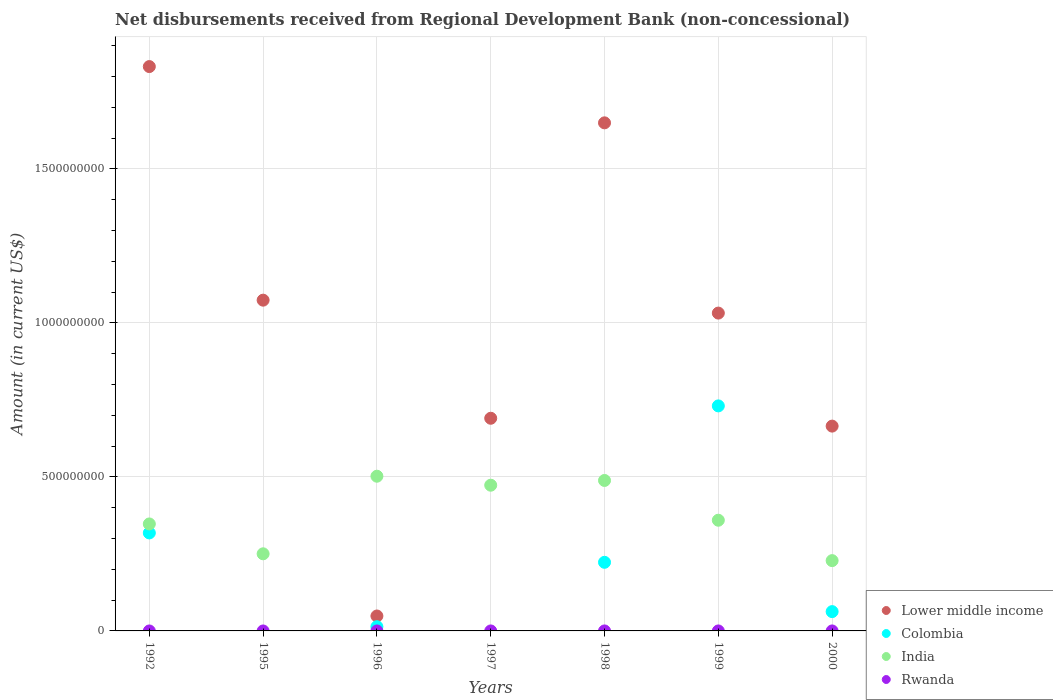How many different coloured dotlines are there?
Offer a very short reply. 3. What is the amount of disbursements received from Regional Development Bank in India in 1992?
Give a very brief answer. 3.47e+08. Across all years, what is the maximum amount of disbursements received from Regional Development Bank in Colombia?
Give a very brief answer. 7.31e+08. What is the total amount of disbursements received from Regional Development Bank in Lower middle income in the graph?
Offer a terse response. 6.99e+09. What is the difference between the amount of disbursements received from Regional Development Bank in Colombia in 1992 and that in 2000?
Your response must be concise. 2.55e+08. What is the difference between the amount of disbursements received from Regional Development Bank in Rwanda in 1992 and the amount of disbursements received from Regional Development Bank in India in 1995?
Your response must be concise. -2.50e+08. What is the average amount of disbursements received from Regional Development Bank in Colombia per year?
Your answer should be very brief. 1.93e+08. In the year 2000, what is the difference between the amount of disbursements received from Regional Development Bank in Colombia and amount of disbursements received from Regional Development Bank in Lower middle income?
Ensure brevity in your answer.  -6.02e+08. In how many years, is the amount of disbursements received from Regional Development Bank in Colombia greater than 100000000 US$?
Give a very brief answer. 3. What is the ratio of the amount of disbursements received from Regional Development Bank in Lower middle income in 1992 to that in 1999?
Provide a succinct answer. 1.78. Is the amount of disbursements received from Regional Development Bank in Colombia in 1996 less than that in 2000?
Offer a terse response. Yes. What is the difference between the highest and the second highest amount of disbursements received from Regional Development Bank in India?
Provide a succinct answer. 1.38e+07. What is the difference between the highest and the lowest amount of disbursements received from Regional Development Bank in India?
Keep it short and to the point. 2.74e+08. In how many years, is the amount of disbursements received from Regional Development Bank in India greater than the average amount of disbursements received from Regional Development Bank in India taken over all years?
Give a very brief answer. 3. Is it the case that in every year, the sum of the amount of disbursements received from Regional Development Bank in Lower middle income and amount of disbursements received from Regional Development Bank in Colombia  is greater than the amount of disbursements received from Regional Development Bank in Rwanda?
Your answer should be compact. Yes. Does the amount of disbursements received from Regional Development Bank in India monotonically increase over the years?
Provide a succinct answer. No. Is the amount of disbursements received from Regional Development Bank in Lower middle income strictly greater than the amount of disbursements received from Regional Development Bank in Rwanda over the years?
Keep it short and to the point. Yes. How many dotlines are there?
Your response must be concise. 3. How many years are there in the graph?
Ensure brevity in your answer.  7. Does the graph contain any zero values?
Provide a short and direct response. Yes. Does the graph contain grids?
Make the answer very short. Yes. Where does the legend appear in the graph?
Provide a short and direct response. Bottom right. How are the legend labels stacked?
Provide a succinct answer. Vertical. What is the title of the graph?
Your answer should be compact. Net disbursements received from Regional Development Bank (non-concessional). What is the label or title of the X-axis?
Provide a short and direct response. Years. What is the Amount (in current US$) in Lower middle income in 1992?
Your response must be concise. 1.83e+09. What is the Amount (in current US$) of Colombia in 1992?
Offer a very short reply. 3.18e+08. What is the Amount (in current US$) in India in 1992?
Make the answer very short. 3.47e+08. What is the Amount (in current US$) in Rwanda in 1992?
Make the answer very short. 0. What is the Amount (in current US$) of Lower middle income in 1995?
Your answer should be very brief. 1.07e+09. What is the Amount (in current US$) in Colombia in 1995?
Make the answer very short. 0. What is the Amount (in current US$) of India in 1995?
Make the answer very short. 2.50e+08. What is the Amount (in current US$) in Lower middle income in 1996?
Give a very brief answer. 4.85e+07. What is the Amount (in current US$) in Colombia in 1996?
Make the answer very short. 1.37e+07. What is the Amount (in current US$) in India in 1996?
Provide a succinct answer. 5.02e+08. What is the Amount (in current US$) in Rwanda in 1996?
Make the answer very short. 0. What is the Amount (in current US$) in Lower middle income in 1997?
Offer a very short reply. 6.91e+08. What is the Amount (in current US$) of India in 1997?
Offer a very short reply. 4.73e+08. What is the Amount (in current US$) of Rwanda in 1997?
Give a very brief answer. 0. What is the Amount (in current US$) of Lower middle income in 1998?
Provide a short and direct response. 1.65e+09. What is the Amount (in current US$) of Colombia in 1998?
Keep it short and to the point. 2.23e+08. What is the Amount (in current US$) in India in 1998?
Your response must be concise. 4.89e+08. What is the Amount (in current US$) in Rwanda in 1998?
Provide a succinct answer. 0. What is the Amount (in current US$) of Lower middle income in 1999?
Your response must be concise. 1.03e+09. What is the Amount (in current US$) in Colombia in 1999?
Offer a very short reply. 7.31e+08. What is the Amount (in current US$) in India in 1999?
Offer a very short reply. 3.59e+08. What is the Amount (in current US$) of Lower middle income in 2000?
Offer a very short reply. 6.65e+08. What is the Amount (in current US$) of Colombia in 2000?
Make the answer very short. 6.27e+07. What is the Amount (in current US$) of India in 2000?
Provide a short and direct response. 2.28e+08. Across all years, what is the maximum Amount (in current US$) of Lower middle income?
Provide a short and direct response. 1.83e+09. Across all years, what is the maximum Amount (in current US$) of Colombia?
Your response must be concise. 7.31e+08. Across all years, what is the maximum Amount (in current US$) of India?
Your answer should be very brief. 5.02e+08. Across all years, what is the minimum Amount (in current US$) in Lower middle income?
Keep it short and to the point. 4.85e+07. Across all years, what is the minimum Amount (in current US$) of Colombia?
Your response must be concise. 0. Across all years, what is the minimum Amount (in current US$) in India?
Provide a succinct answer. 2.28e+08. What is the total Amount (in current US$) of Lower middle income in the graph?
Make the answer very short. 6.99e+09. What is the total Amount (in current US$) in Colombia in the graph?
Ensure brevity in your answer.  1.35e+09. What is the total Amount (in current US$) of India in the graph?
Your response must be concise. 2.65e+09. What is the total Amount (in current US$) of Rwanda in the graph?
Ensure brevity in your answer.  0. What is the difference between the Amount (in current US$) of Lower middle income in 1992 and that in 1995?
Ensure brevity in your answer.  7.58e+08. What is the difference between the Amount (in current US$) of India in 1992 and that in 1995?
Give a very brief answer. 9.70e+07. What is the difference between the Amount (in current US$) in Lower middle income in 1992 and that in 1996?
Offer a terse response. 1.78e+09. What is the difference between the Amount (in current US$) of Colombia in 1992 and that in 1996?
Provide a succinct answer. 3.04e+08. What is the difference between the Amount (in current US$) of India in 1992 and that in 1996?
Your answer should be very brief. -1.55e+08. What is the difference between the Amount (in current US$) of Lower middle income in 1992 and that in 1997?
Offer a very short reply. 1.14e+09. What is the difference between the Amount (in current US$) in India in 1992 and that in 1997?
Keep it short and to the point. -1.26e+08. What is the difference between the Amount (in current US$) in Lower middle income in 1992 and that in 1998?
Your answer should be very brief. 1.83e+08. What is the difference between the Amount (in current US$) of Colombia in 1992 and that in 1998?
Your answer should be very brief. 9.54e+07. What is the difference between the Amount (in current US$) in India in 1992 and that in 1998?
Your answer should be compact. -1.41e+08. What is the difference between the Amount (in current US$) in Lower middle income in 1992 and that in 1999?
Your response must be concise. 8.00e+08. What is the difference between the Amount (in current US$) in Colombia in 1992 and that in 1999?
Your response must be concise. -4.12e+08. What is the difference between the Amount (in current US$) in India in 1992 and that in 1999?
Ensure brevity in your answer.  -1.21e+07. What is the difference between the Amount (in current US$) in Lower middle income in 1992 and that in 2000?
Give a very brief answer. 1.17e+09. What is the difference between the Amount (in current US$) in Colombia in 1992 and that in 2000?
Your response must be concise. 2.55e+08. What is the difference between the Amount (in current US$) in India in 1992 and that in 2000?
Provide a succinct answer. 1.19e+08. What is the difference between the Amount (in current US$) in Lower middle income in 1995 and that in 1996?
Provide a short and direct response. 1.03e+09. What is the difference between the Amount (in current US$) in India in 1995 and that in 1996?
Keep it short and to the point. -2.52e+08. What is the difference between the Amount (in current US$) of Lower middle income in 1995 and that in 1997?
Offer a terse response. 3.83e+08. What is the difference between the Amount (in current US$) in India in 1995 and that in 1997?
Offer a very short reply. -2.23e+08. What is the difference between the Amount (in current US$) in Lower middle income in 1995 and that in 1998?
Make the answer very short. -5.76e+08. What is the difference between the Amount (in current US$) of India in 1995 and that in 1998?
Make the answer very short. -2.38e+08. What is the difference between the Amount (in current US$) in Lower middle income in 1995 and that in 1999?
Give a very brief answer. 4.20e+07. What is the difference between the Amount (in current US$) of India in 1995 and that in 1999?
Keep it short and to the point. -1.09e+08. What is the difference between the Amount (in current US$) in Lower middle income in 1995 and that in 2000?
Your response must be concise. 4.09e+08. What is the difference between the Amount (in current US$) in India in 1995 and that in 2000?
Give a very brief answer. 2.21e+07. What is the difference between the Amount (in current US$) in Lower middle income in 1996 and that in 1997?
Provide a succinct answer. -6.42e+08. What is the difference between the Amount (in current US$) in India in 1996 and that in 1997?
Offer a very short reply. 2.92e+07. What is the difference between the Amount (in current US$) in Lower middle income in 1996 and that in 1998?
Keep it short and to the point. -1.60e+09. What is the difference between the Amount (in current US$) of Colombia in 1996 and that in 1998?
Make the answer very short. -2.09e+08. What is the difference between the Amount (in current US$) of India in 1996 and that in 1998?
Provide a short and direct response. 1.38e+07. What is the difference between the Amount (in current US$) in Lower middle income in 1996 and that in 1999?
Your answer should be very brief. -9.84e+08. What is the difference between the Amount (in current US$) in Colombia in 1996 and that in 1999?
Your answer should be very brief. -7.17e+08. What is the difference between the Amount (in current US$) of India in 1996 and that in 1999?
Keep it short and to the point. 1.43e+08. What is the difference between the Amount (in current US$) in Lower middle income in 1996 and that in 2000?
Offer a very short reply. -6.17e+08. What is the difference between the Amount (in current US$) in Colombia in 1996 and that in 2000?
Ensure brevity in your answer.  -4.90e+07. What is the difference between the Amount (in current US$) in India in 1996 and that in 2000?
Keep it short and to the point. 2.74e+08. What is the difference between the Amount (in current US$) in Lower middle income in 1997 and that in 1998?
Offer a very short reply. -9.59e+08. What is the difference between the Amount (in current US$) in India in 1997 and that in 1998?
Offer a very short reply. -1.54e+07. What is the difference between the Amount (in current US$) of Lower middle income in 1997 and that in 1999?
Keep it short and to the point. -3.42e+08. What is the difference between the Amount (in current US$) of India in 1997 and that in 1999?
Make the answer very short. 1.14e+08. What is the difference between the Amount (in current US$) in Lower middle income in 1997 and that in 2000?
Offer a very short reply. 2.55e+07. What is the difference between the Amount (in current US$) in India in 1997 and that in 2000?
Your response must be concise. 2.45e+08. What is the difference between the Amount (in current US$) of Lower middle income in 1998 and that in 1999?
Your answer should be very brief. 6.18e+08. What is the difference between the Amount (in current US$) in Colombia in 1998 and that in 1999?
Offer a terse response. -5.08e+08. What is the difference between the Amount (in current US$) of India in 1998 and that in 1999?
Offer a very short reply. 1.29e+08. What is the difference between the Amount (in current US$) of Lower middle income in 1998 and that in 2000?
Keep it short and to the point. 9.85e+08. What is the difference between the Amount (in current US$) in Colombia in 1998 and that in 2000?
Offer a terse response. 1.60e+08. What is the difference between the Amount (in current US$) of India in 1998 and that in 2000?
Your answer should be very brief. 2.60e+08. What is the difference between the Amount (in current US$) of Lower middle income in 1999 and that in 2000?
Provide a short and direct response. 3.67e+08. What is the difference between the Amount (in current US$) of Colombia in 1999 and that in 2000?
Offer a very short reply. 6.68e+08. What is the difference between the Amount (in current US$) of India in 1999 and that in 2000?
Your response must be concise. 1.31e+08. What is the difference between the Amount (in current US$) in Lower middle income in 1992 and the Amount (in current US$) in India in 1995?
Make the answer very short. 1.58e+09. What is the difference between the Amount (in current US$) of Colombia in 1992 and the Amount (in current US$) of India in 1995?
Give a very brief answer. 6.78e+07. What is the difference between the Amount (in current US$) in Lower middle income in 1992 and the Amount (in current US$) in Colombia in 1996?
Ensure brevity in your answer.  1.82e+09. What is the difference between the Amount (in current US$) of Lower middle income in 1992 and the Amount (in current US$) of India in 1996?
Keep it short and to the point. 1.33e+09. What is the difference between the Amount (in current US$) of Colombia in 1992 and the Amount (in current US$) of India in 1996?
Provide a short and direct response. -1.84e+08. What is the difference between the Amount (in current US$) in Lower middle income in 1992 and the Amount (in current US$) in India in 1997?
Provide a short and direct response. 1.36e+09. What is the difference between the Amount (in current US$) of Colombia in 1992 and the Amount (in current US$) of India in 1997?
Keep it short and to the point. -1.55e+08. What is the difference between the Amount (in current US$) in Lower middle income in 1992 and the Amount (in current US$) in Colombia in 1998?
Provide a short and direct response. 1.61e+09. What is the difference between the Amount (in current US$) in Lower middle income in 1992 and the Amount (in current US$) in India in 1998?
Ensure brevity in your answer.  1.34e+09. What is the difference between the Amount (in current US$) in Colombia in 1992 and the Amount (in current US$) in India in 1998?
Offer a very short reply. -1.70e+08. What is the difference between the Amount (in current US$) of Lower middle income in 1992 and the Amount (in current US$) of Colombia in 1999?
Offer a terse response. 1.10e+09. What is the difference between the Amount (in current US$) in Lower middle income in 1992 and the Amount (in current US$) in India in 1999?
Offer a very short reply. 1.47e+09. What is the difference between the Amount (in current US$) in Colombia in 1992 and the Amount (in current US$) in India in 1999?
Your answer should be compact. -4.13e+07. What is the difference between the Amount (in current US$) in Lower middle income in 1992 and the Amount (in current US$) in Colombia in 2000?
Keep it short and to the point. 1.77e+09. What is the difference between the Amount (in current US$) of Lower middle income in 1992 and the Amount (in current US$) of India in 2000?
Give a very brief answer. 1.60e+09. What is the difference between the Amount (in current US$) in Colombia in 1992 and the Amount (in current US$) in India in 2000?
Make the answer very short. 8.99e+07. What is the difference between the Amount (in current US$) in Lower middle income in 1995 and the Amount (in current US$) in Colombia in 1996?
Give a very brief answer. 1.06e+09. What is the difference between the Amount (in current US$) of Lower middle income in 1995 and the Amount (in current US$) of India in 1996?
Your answer should be compact. 5.72e+08. What is the difference between the Amount (in current US$) of Lower middle income in 1995 and the Amount (in current US$) of India in 1997?
Your answer should be very brief. 6.01e+08. What is the difference between the Amount (in current US$) of Lower middle income in 1995 and the Amount (in current US$) of Colombia in 1998?
Your response must be concise. 8.51e+08. What is the difference between the Amount (in current US$) of Lower middle income in 1995 and the Amount (in current US$) of India in 1998?
Ensure brevity in your answer.  5.85e+08. What is the difference between the Amount (in current US$) in Lower middle income in 1995 and the Amount (in current US$) in Colombia in 1999?
Provide a short and direct response. 3.43e+08. What is the difference between the Amount (in current US$) in Lower middle income in 1995 and the Amount (in current US$) in India in 1999?
Your answer should be compact. 7.15e+08. What is the difference between the Amount (in current US$) in Lower middle income in 1995 and the Amount (in current US$) in Colombia in 2000?
Your response must be concise. 1.01e+09. What is the difference between the Amount (in current US$) in Lower middle income in 1995 and the Amount (in current US$) in India in 2000?
Your answer should be very brief. 8.46e+08. What is the difference between the Amount (in current US$) of Lower middle income in 1996 and the Amount (in current US$) of India in 1997?
Ensure brevity in your answer.  -4.25e+08. What is the difference between the Amount (in current US$) in Colombia in 1996 and the Amount (in current US$) in India in 1997?
Provide a short and direct response. -4.59e+08. What is the difference between the Amount (in current US$) in Lower middle income in 1996 and the Amount (in current US$) in Colombia in 1998?
Your response must be concise. -1.74e+08. What is the difference between the Amount (in current US$) in Lower middle income in 1996 and the Amount (in current US$) in India in 1998?
Provide a succinct answer. -4.40e+08. What is the difference between the Amount (in current US$) in Colombia in 1996 and the Amount (in current US$) in India in 1998?
Provide a succinct answer. -4.75e+08. What is the difference between the Amount (in current US$) of Lower middle income in 1996 and the Amount (in current US$) of Colombia in 1999?
Your answer should be very brief. -6.82e+08. What is the difference between the Amount (in current US$) in Lower middle income in 1996 and the Amount (in current US$) in India in 1999?
Give a very brief answer. -3.11e+08. What is the difference between the Amount (in current US$) of Colombia in 1996 and the Amount (in current US$) of India in 1999?
Provide a short and direct response. -3.46e+08. What is the difference between the Amount (in current US$) of Lower middle income in 1996 and the Amount (in current US$) of Colombia in 2000?
Keep it short and to the point. -1.42e+07. What is the difference between the Amount (in current US$) of Lower middle income in 1996 and the Amount (in current US$) of India in 2000?
Offer a terse response. -1.80e+08. What is the difference between the Amount (in current US$) of Colombia in 1996 and the Amount (in current US$) of India in 2000?
Your response must be concise. -2.15e+08. What is the difference between the Amount (in current US$) of Lower middle income in 1997 and the Amount (in current US$) of Colombia in 1998?
Provide a succinct answer. 4.68e+08. What is the difference between the Amount (in current US$) in Lower middle income in 1997 and the Amount (in current US$) in India in 1998?
Give a very brief answer. 2.02e+08. What is the difference between the Amount (in current US$) of Lower middle income in 1997 and the Amount (in current US$) of Colombia in 1999?
Provide a short and direct response. -4.01e+07. What is the difference between the Amount (in current US$) of Lower middle income in 1997 and the Amount (in current US$) of India in 1999?
Keep it short and to the point. 3.31e+08. What is the difference between the Amount (in current US$) of Lower middle income in 1997 and the Amount (in current US$) of Colombia in 2000?
Provide a short and direct response. 6.28e+08. What is the difference between the Amount (in current US$) of Lower middle income in 1997 and the Amount (in current US$) of India in 2000?
Your answer should be very brief. 4.62e+08. What is the difference between the Amount (in current US$) in Lower middle income in 1998 and the Amount (in current US$) in Colombia in 1999?
Offer a terse response. 9.19e+08. What is the difference between the Amount (in current US$) of Lower middle income in 1998 and the Amount (in current US$) of India in 1999?
Give a very brief answer. 1.29e+09. What is the difference between the Amount (in current US$) of Colombia in 1998 and the Amount (in current US$) of India in 1999?
Provide a succinct answer. -1.37e+08. What is the difference between the Amount (in current US$) of Lower middle income in 1998 and the Amount (in current US$) of Colombia in 2000?
Provide a short and direct response. 1.59e+09. What is the difference between the Amount (in current US$) of Lower middle income in 1998 and the Amount (in current US$) of India in 2000?
Give a very brief answer. 1.42e+09. What is the difference between the Amount (in current US$) in Colombia in 1998 and the Amount (in current US$) in India in 2000?
Provide a short and direct response. -5.48e+06. What is the difference between the Amount (in current US$) of Lower middle income in 1999 and the Amount (in current US$) of Colombia in 2000?
Make the answer very short. 9.69e+08. What is the difference between the Amount (in current US$) of Lower middle income in 1999 and the Amount (in current US$) of India in 2000?
Your answer should be very brief. 8.04e+08. What is the difference between the Amount (in current US$) in Colombia in 1999 and the Amount (in current US$) in India in 2000?
Offer a very short reply. 5.02e+08. What is the average Amount (in current US$) of Lower middle income per year?
Offer a very short reply. 9.99e+08. What is the average Amount (in current US$) in Colombia per year?
Make the answer very short. 1.93e+08. What is the average Amount (in current US$) in India per year?
Your answer should be very brief. 3.79e+08. In the year 1992, what is the difference between the Amount (in current US$) of Lower middle income and Amount (in current US$) of Colombia?
Your answer should be compact. 1.51e+09. In the year 1992, what is the difference between the Amount (in current US$) in Lower middle income and Amount (in current US$) in India?
Your response must be concise. 1.49e+09. In the year 1992, what is the difference between the Amount (in current US$) in Colombia and Amount (in current US$) in India?
Give a very brief answer. -2.92e+07. In the year 1995, what is the difference between the Amount (in current US$) in Lower middle income and Amount (in current US$) in India?
Offer a terse response. 8.24e+08. In the year 1996, what is the difference between the Amount (in current US$) in Lower middle income and Amount (in current US$) in Colombia?
Your answer should be very brief. 3.48e+07. In the year 1996, what is the difference between the Amount (in current US$) of Lower middle income and Amount (in current US$) of India?
Your answer should be very brief. -4.54e+08. In the year 1996, what is the difference between the Amount (in current US$) of Colombia and Amount (in current US$) of India?
Offer a terse response. -4.89e+08. In the year 1997, what is the difference between the Amount (in current US$) of Lower middle income and Amount (in current US$) of India?
Make the answer very short. 2.17e+08. In the year 1998, what is the difference between the Amount (in current US$) in Lower middle income and Amount (in current US$) in Colombia?
Keep it short and to the point. 1.43e+09. In the year 1998, what is the difference between the Amount (in current US$) in Lower middle income and Amount (in current US$) in India?
Your response must be concise. 1.16e+09. In the year 1998, what is the difference between the Amount (in current US$) of Colombia and Amount (in current US$) of India?
Ensure brevity in your answer.  -2.66e+08. In the year 1999, what is the difference between the Amount (in current US$) of Lower middle income and Amount (in current US$) of Colombia?
Make the answer very short. 3.01e+08. In the year 1999, what is the difference between the Amount (in current US$) in Lower middle income and Amount (in current US$) in India?
Make the answer very short. 6.73e+08. In the year 1999, what is the difference between the Amount (in current US$) in Colombia and Amount (in current US$) in India?
Give a very brief answer. 3.71e+08. In the year 2000, what is the difference between the Amount (in current US$) of Lower middle income and Amount (in current US$) of Colombia?
Your answer should be compact. 6.02e+08. In the year 2000, what is the difference between the Amount (in current US$) in Lower middle income and Amount (in current US$) in India?
Your answer should be compact. 4.37e+08. In the year 2000, what is the difference between the Amount (in current US$) in Colombia and Amount (in current US$) in India?
Provide a short and direct response. -1.66e+08. What is the ratio of the Amount (in current US$) of Lower middle income in 1992 to that in 1995?
Your response must be concise. 1.71. What is the ratio of the Amount (in current US$) of India in 1992 to that in 1995?
Provide a short and direct response. 1.39. What is the ratio of the Amount (in current US$) of Lower middle income in 1992 to that in 1996?
Keep it short and to the point. 37.81. What is the ratio of the Amount (in current US$) in Colombia in 1992 to that in 1996?
Your answer should be compact. 23.26. What is the ratio of the Amount (in current US$) of India in 1992 to that in 1996?
Your answer should be compact. 0.69. What is the ratio of the Amount (in current US$) in Lower middle income in 1992 to that in 1997?
Provide a short and direct response. 2.65. What is the ratio of the Amount (in current US$) in India in 1992 to that in 1997?
Offer a terse response. 0.73. What is the ratio of the Amount (in current US$) in Lower middle income in 1992 to that in 1998?
Your answer should be compact. 1.11. What is the ratio of the Amount (in current US$) of Colombia in 1992 to that in 1998?
Offer a terse response. 1.43. What is the ratio of the Amount (in current US$) in India in 1992 to that in 1998?
Your answer should be compact. 0.71. What is the ratio of the Amount (in current US$) in Lower middle income in 1992 to that in 1999?
Offer a very short reply. 1.78. What is the ratio of the Amount (in current US$) of Colombia in 1992 to that in 1999?
Your response must be concise. 0.44. What is the ratio of the Amount (in current US$) of India in 1992 to that in 1999?
Make the answer very short. 0.97. What is the ratio of the Amount (in current US$) of Lower middle income in 1992 to that in 2000?
Offer a very short reply. 2.76. What is the ratio of the Amount (in current US$) in Colombia in 1992 to that in 2000?
Keep it short and to the point. 5.08. What is the ratio of the Amount (in current US$) in India in 1992 to that in 2000?
Offer a terse response. 1.52. What is the ratio of the Amount (in current US$) of Lower middle income in 1995 to that in 1996?
Make the answer very short. 22.16. What is the ratio of the Amount (in current US$) in India in 1995 to that in 1996?
Give a very brief answer. 0.5. What is the ratio of the Amount (in current US$) of Lower middle income in 1995 to that in 1997?
Give a very brief answer. 1.56. What is the ratio of the Amount (in current US$) in India in 1995 to that in 1997?
Give a very brief answer. 0.53. What is the ratio of the Amount (in current US$) in Lower middle income in 1995 to that in 1998?
Offer a terse response. 0.65. What is the ratio of the Amount (in current US$) in India in 1995 to that in 1998?
Your answer should be very brief. 0.51. What is the ratio of the Amount (in current US$) in Lower middle income in 1995 to that in 1999?
Your answer should be compact. 1.04. What is the ratio of the Amount (in current US$) in India in 1995 to that in 1999?
Your response must be concise. 0.7. What is the ratio of the Amount (in current US$) in Lower middle income in 1995 to that in 2000?
Make the answer very short. 1.61. What is the ratio of the Amount (in current US$) in India in 1995 to that in 2000?
Provide a succinct answer. 1.1. What is the ratio of the Amount (in current US$) of Lower middle income in 1996 to that in 1997?
Provide a short and direct response. 0.07. What is the ratio of the Amount (in current US$) in India in 1996 to that in 1997?
Offer a very short reply. 1.06. What is the ratio of the Amount (in current US$) of Lower middle income in 1996 to that in 1998?
Your response must be concise. 0.03. What is the ratio of the Amount (in current US$) in Colombia in 1996 to that in 1998?
Ensure brevity in your answer.  0.06. What is the ratio of the Amount (in current US$) in India in 1996 to that in 1998?
Give a very brief answer. 1.03. What is the ratio of the Amount (in current US$) of Lower middle income in 1996 to that in 1999?
Keep it short and to the point. 0.05. What is the ratio of the Amount (in current US$) in Colombia in 1996 to that in 1999?
Your answer should be very brief. 0.02. What is the ratio of the Amount (in current US$) in India in 1996 to that in 1999?
Give a very brief answer. 1.4. What is the ratio of the Amount (in current US$) of Lower middle income in 1996 to that in 2000?
Offer a terse response. 0.07. What is the ratio of the Amount (in current US$) of Colombia in 1996 to that in 2000?
Give a very brief answer. 0.22. What is the ratio of the Amount (in current US$) in India in 1996 to that in 2000?
Provide a short and direct response. 2.2. What is the ratio of the Amount (in current US$) in Lower middle income in 1997 to that in 1998?
Give a very brief answer. 0.42. What is the ratio of the Amount (in current US$) in India in 1997 to that in 1998?
Ensure brevity in your answer.  0.97. What is the ratio of the Amount (in current US$) of Lower middle income in 1997 to that in 1999?
Your answer should be very brief. 0.67. What is the ratio of the Amount (in current US$) of India in 1997 to that in 1999?
Your answer should be compact. 1.32. What is the ratio of the Amount (in current US$) in Lower middle income in 1997 to that in 2000?
Provide a succinct answer. 1.04. What is the ratio of the Amount (in current US$) in India in 1997 to that in 2000?
Ensure brevity in your answer.  2.07. What is the ratio of the Amount (in current US$) in Lower middle income in 1998 to that in 1999?
Give a very brief answer. 1.6. What is the ratio of the Amount (in current US$) in Colombia in 1998 to that in 1999?
Offer a terse response. 0.3. What is the ratio of the Amount (in current US$) of India in 1998 to that in 1999?
Offer a terse response. 1.36. What is the ratio of the Amount (in current US$) in Lower middle income in 1998 to that in 2000?
Provide a short and direct response. 2.48. What is the ratio of the Amount (in current US$) of Colombia in 1998 to that in 2000?
Offer a terse response. 3.55. What is the ratio of the Amount (in current US$) in India in 1998 to that in 2000?
Ensure brevity in your answer.  2.14. What is the ratio of the Amount (in current US$) of Lower middle income in 1999 to that in 2000?
Give a very brief answer. 1.55. What is the ratio of the Amount (in current US$) in Colombia in 1999 to that in 2000?
Keep it short and to the point. 11.66. What is the ratio of the Amount (in current US$) of India in 1999 to that in 2000?
Your response must be concise. 1.57. What is the difference between the highest and the second highest Amount (in current US$) in Lower middle income?
Keep it short and to the point. 1.83e+08. What is the difference between the highest and the second highest Amount (in current US$) of Colombia?
Give a very brief answer. 4.12e+08. What is the difference between the highest and the second highest Amount (in current US$) in India?
Give a very brief answer. 1.38e+07. What is the difference between the highest and the lowest Amount (in current US$) of Lower middle income?
Ensure brevity in your answer.  1.78e+09. What is the difference between the highest and the lowest Amount (in current US$) of Colombia?
Provide a short and direct response. 7.31e+08. What is the difference between the highest and the lowest Amount (in current US$) of India?
Ensure brevity in your answer.  2.74e+08. 